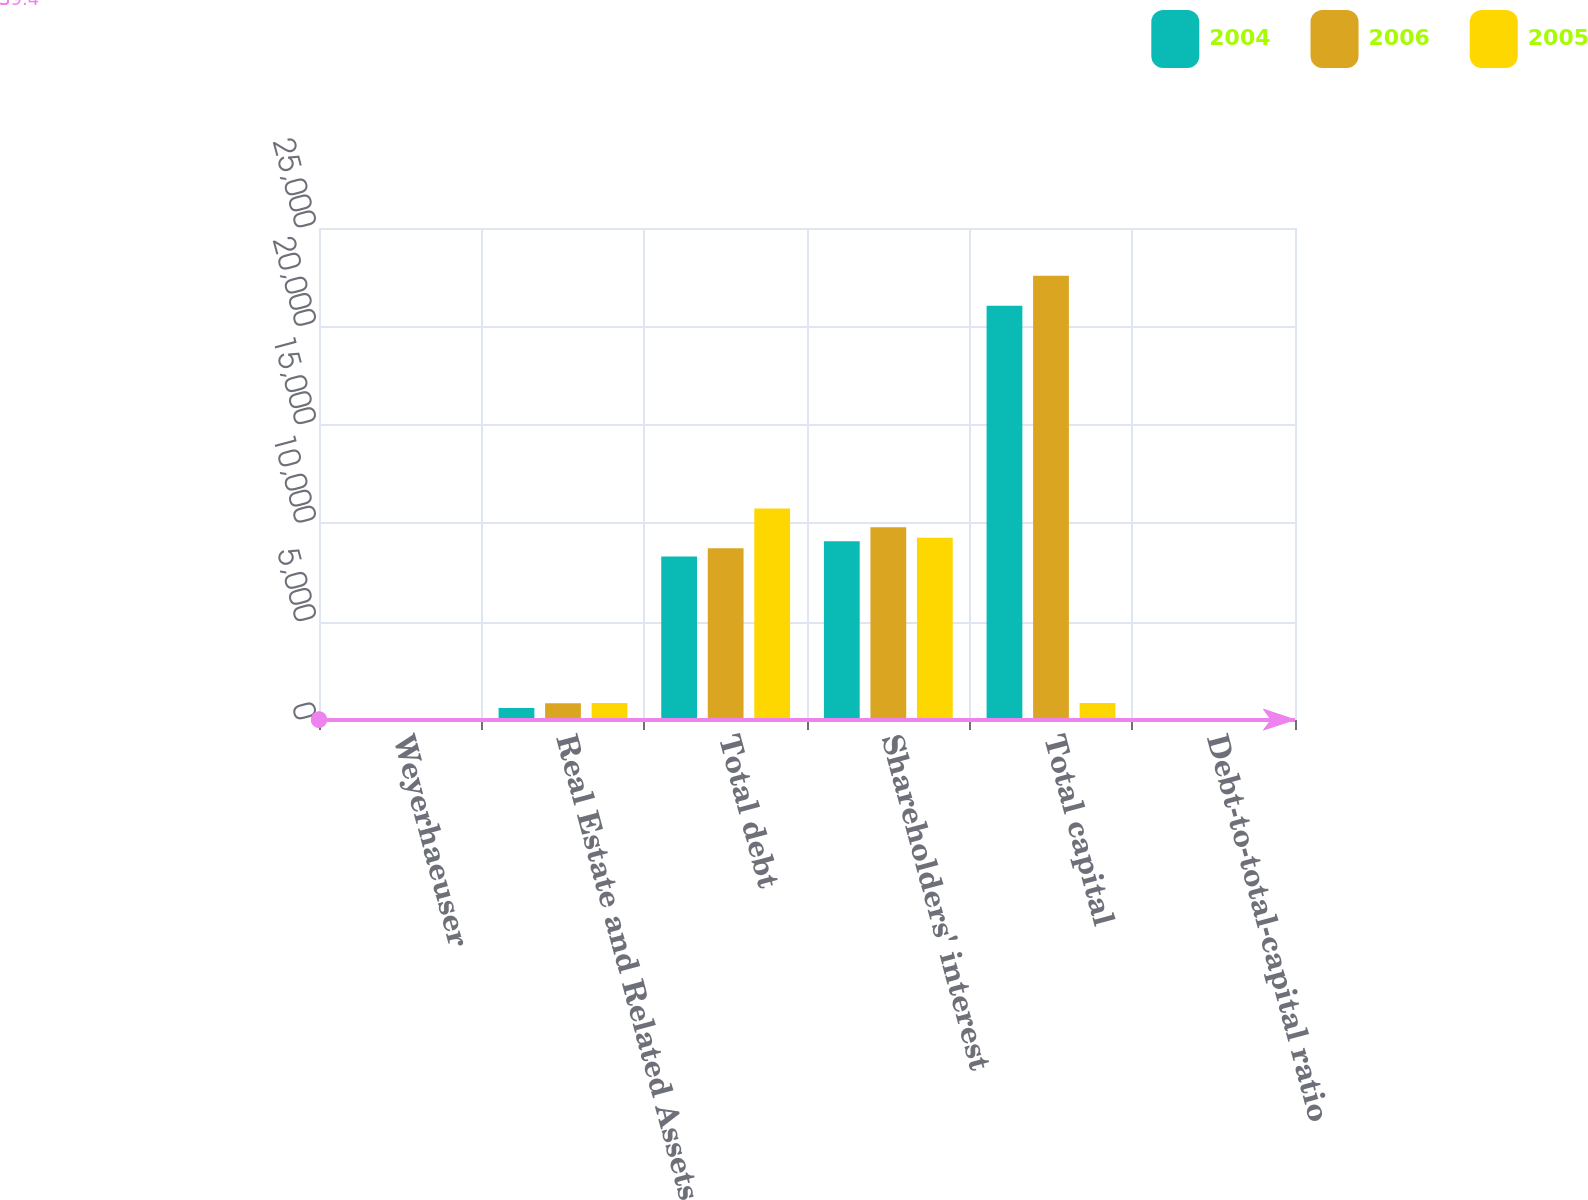Convert chart to OTSL. <chart><loc_0><loc_0><loc_500><loc_500><stacked_bar_chart><ecel><fcel>Weyerhaeuser<fcel>Real Estate and Related Assets<fcel>Total debt<fcel>Shareholders' interest<fcel>Total capital<fcel>Debt-to-total-capital ratio<nl><fcel>2004<fcel>72<fcel>606<fcel>8303<fcel>9085<fcel>21049<fcel>39.4<nl><fcel>2006<fcel>3<fcel>851<fcel>8731<fcel>9800<fcel>22574<fcel>38.7<nl><fcel>2005<fcel>3<fcel>867<fcel>10741<fcel>9255<fcel>867<fcel>43.7<nl></chart> 